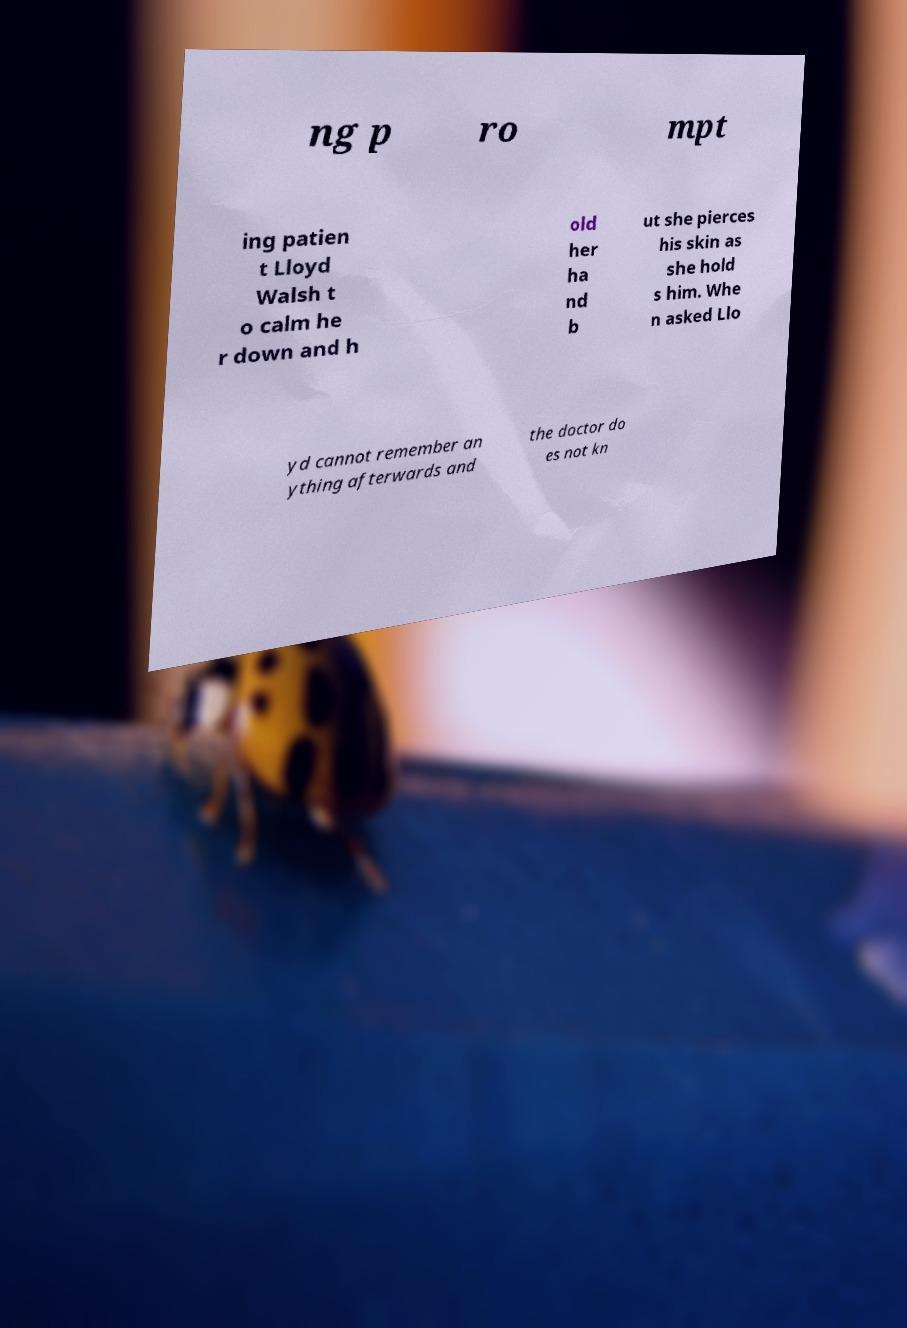Please identify and transcribe the text found in this image. ng p ro mpt ing patien t Lloyd Walsh t o calm he r down and h old her ha nd b ut she pierces his skin as she hold s him. Whe n asked Llo yd cannot remember an ything afterwards and the doctor do es not kn 